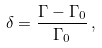Convert formula to latex. <formula><loc_0><loc_0><loc_500><loc_500>\delta = { \frac { \Gamma - \Gamma _ { 0 } } { \Gamma _ { 0 } } } \, ,</formula> 